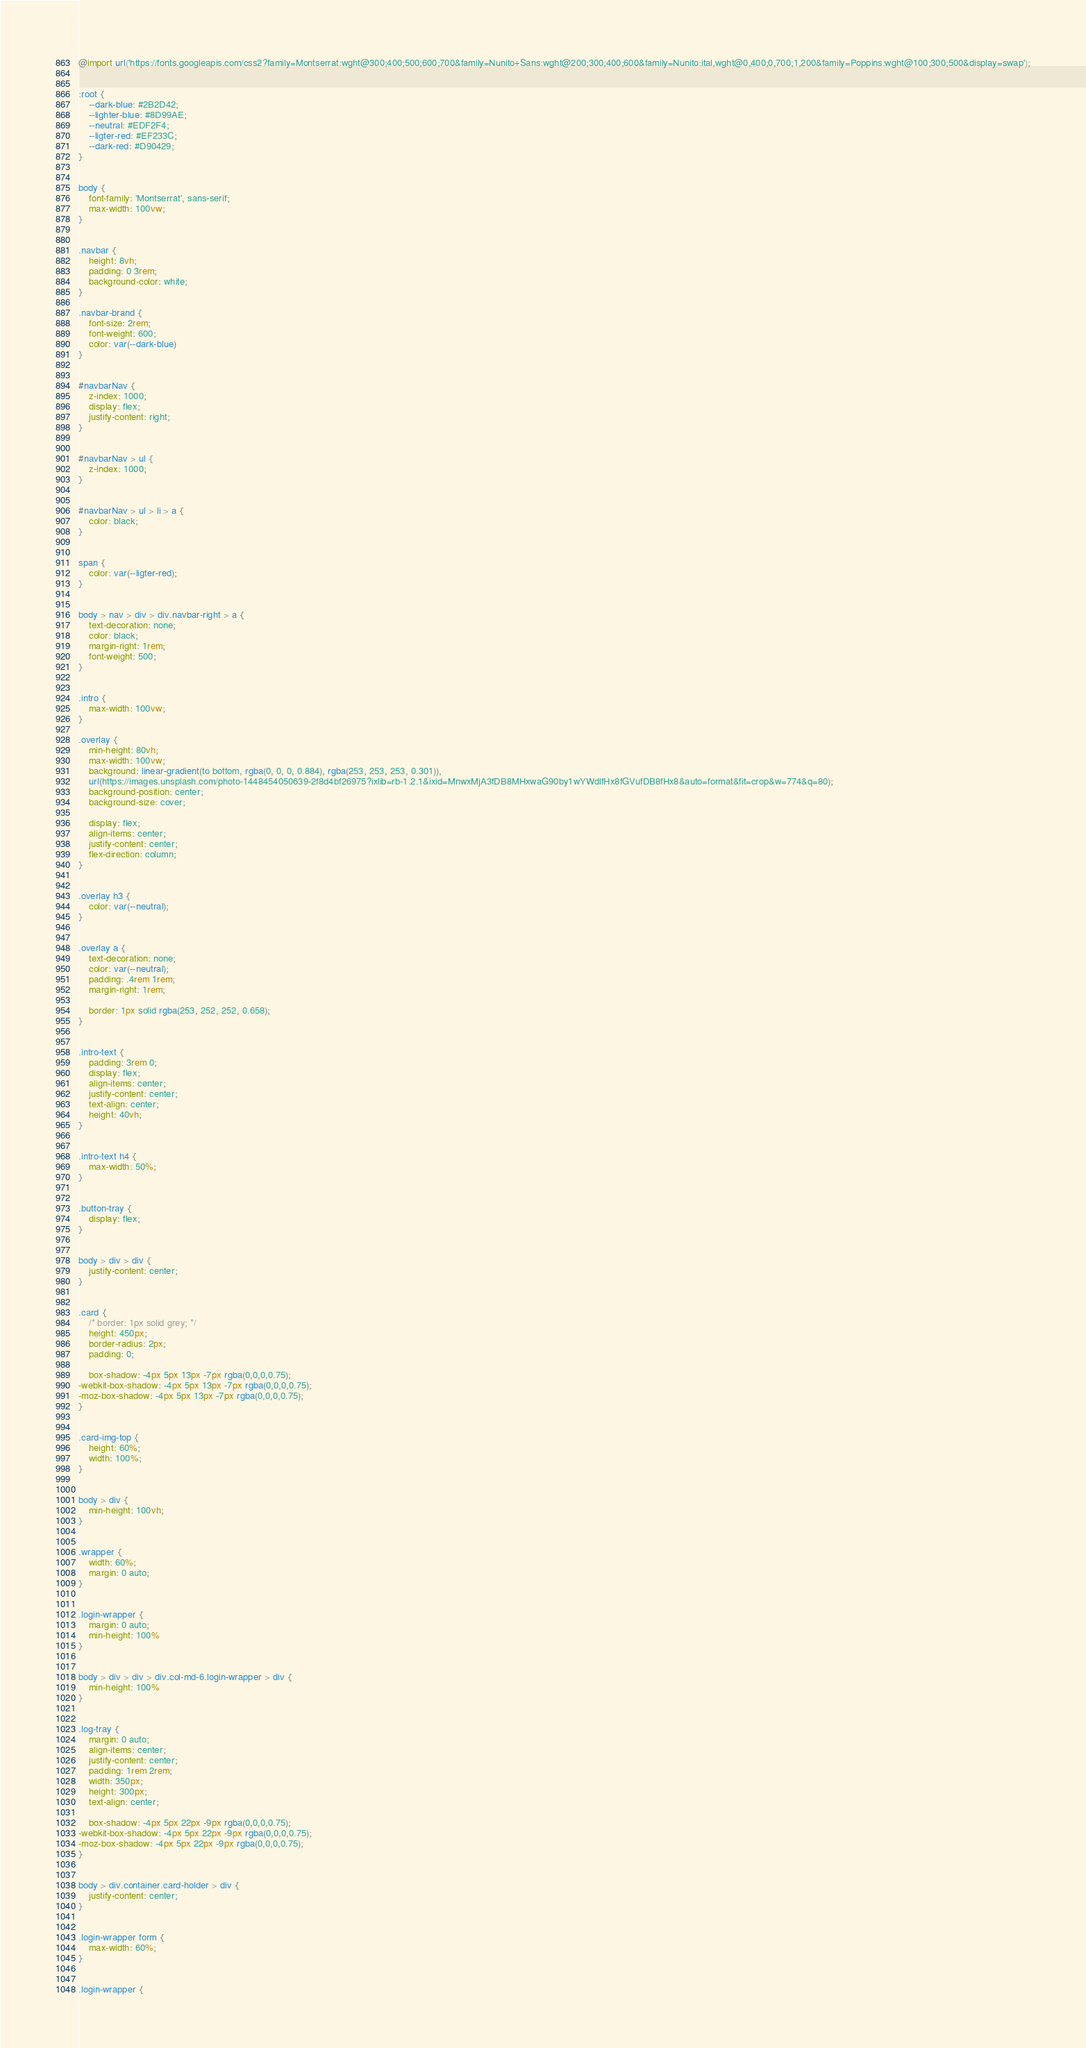Convert code to text. <code><loc_0><loc_0><loc_500><loc_500><_CSS_>@import url('https://fonts.googleapis.com/css2?family=Montserrat:wght@300;400;500;600;700&family=Nunito+Sans:wght@200;300;400;600&family=Nunito:ital,wght@0,400;0,700;1,200&family=Poppins:wght@100;300;500&display=swap');


:root {
    --dark-blue: #2B2D42;
    --lighter-blue: #8D99AE;
    --neutral: #EDF2F4;
    --ligter-red: #EF233C;
    --dark-red: #D90429;
}


body {
    font-family: 'Montserrat', sans-serif;
    max-width: 100vw;
}


.navbar {
    height: 8vh;
    padding: 0 3rem;
    background-color: white;
}

.navbar-brand {
    font-size: 2rem;
    font-weight: 600;
    color: var(--dark-blue)
}


#navbarNav {
    z-index: 1000;
    display: flex;
    justify-content: right;
}


#navbarNav > ul {
    z-index: 1000;
}


#navbarNav > ul > li > a {
    color: black;
}


span {
    color: var(--ligter-red);
}


body > nav > div > div.navbar-right > a {
    text-decoration: none;
    color: black;
    margin-right: 1rem;
    font-weight: 500;
}


.intro {
    max-width: 100vw;
}

.overlay {
    min-height: 80vh;
    max-width: 100vw;
    background: linear-gradient(to bottom, rgba(0, 0, 0, 0.884), rgba(253, 253, 253, 0.301)),
    url(https://images.unsplash.com/photo-1448454050639-2f8d4bf26975?ixlib=rb-1.2.1&ixid=MnwxMjA3fDB8MHxwaG90by1wYWdlfHx8fGVufDB8fHx8&auto=format&fit=crop&w=774&q=80);
    background-position: center;
    background-size: cover;

    display: flex;
    align-items: center;
    justify-content: center;
    flex-direction: column;
}


.overlay h3 {
    color: var(--neutral);
}


.overlay a {
    text-decoration: none;
    color: var(--neutral);
    padding: .4rem 1rem;
    margin-right: 1rem;

    border: 1px solid rgba(253, 252, 252, 0.658);
}


.intro-text {
    padding: 3rem 0;
    display: flex;
    align-items: center;
    justify-content: center;
    text-align: center;
    height: 40vh;
}


.intro-text h4 {
    max-width: 50%;
}


.button-tray {
    display: flex;
}


body > div > div {
    justify-content: center;
}


.card {
    /* border: 1px solid grey; */
    height: 450px;
    border-radius: 2px;
    padding: 0;

    box-shadow: -4px 5px 13px -7px rgba(0,0,0,0.75);
-webkit-box-shadow: -4px 5px 13px -7px rgba(0,0,0,0.75);
-moz-box-shadow: -4px 5px 13px -7px rgba(0,0,0,0.75);
}


.card-img-top {
    height: 60%;
    width: 100%;
}


body > div {
    min-height: 100vh;
}


.wrapper {
    width: 60%;
    margin: 0 auto;
}


.login-wrapper {
    margin: 0 auto;
    min-height: 100%
}


body > div > div > div.col-md-6.login-wrapper > div {
    min-height: 100%
}


.log-tray {
    margin: 0 auto;
    align-items: center;
    justify-content: center;
    padding: 1rem 2rem;
    width: 350px;
    height: 300px;
    text-align: center;

    box-shadow: -4px 5px 22px -9px rgba(0,0,0,0.75);
-webkit-box-shadow: -4px 5px 22px -9px rgba(0,0,0,0.75);
-moz-box-shadow: -4px 5px 22px -9px rgba(0,0,0,0.75);
}


body > div.container.card-holder > div {
    justify-content: center;
}


.login-wrapper form {
    max-width: 60%;
}


.login-wrapper {</code> 